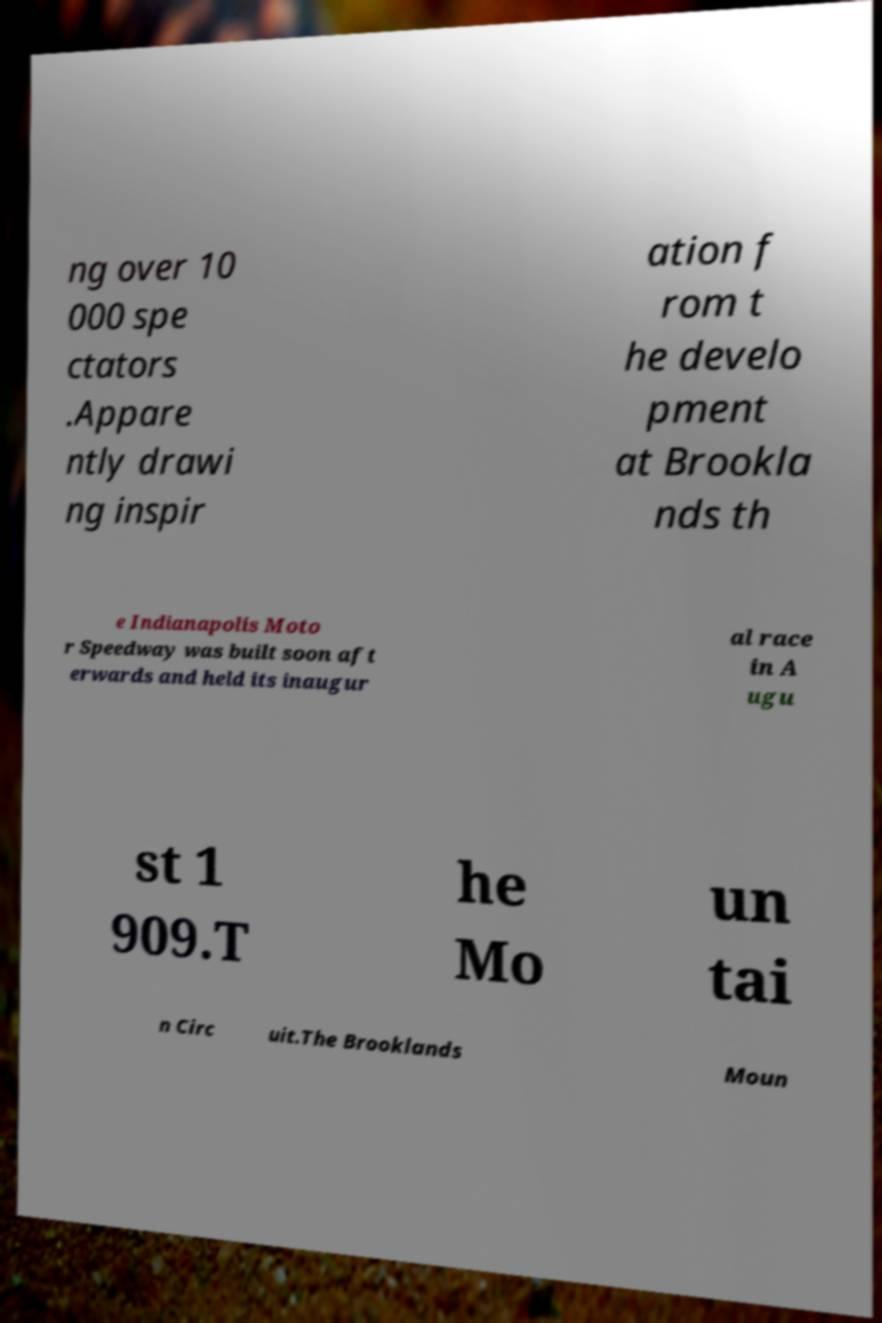Can you read and provide the text displayed in the image?This photo seems to have some interesting text. Can you extract and type it out for me? ng over 10 000 spe ctators .Appare ntly drawi ng inspir ation f rom t he develo pment at Brookla nds th e Indianapolis Moto r Speedway was built soon aft erwards and held its inaugur al race in A ugu st 1 909.T he Mo un tai n Circ uit.The Brooklands Moun 